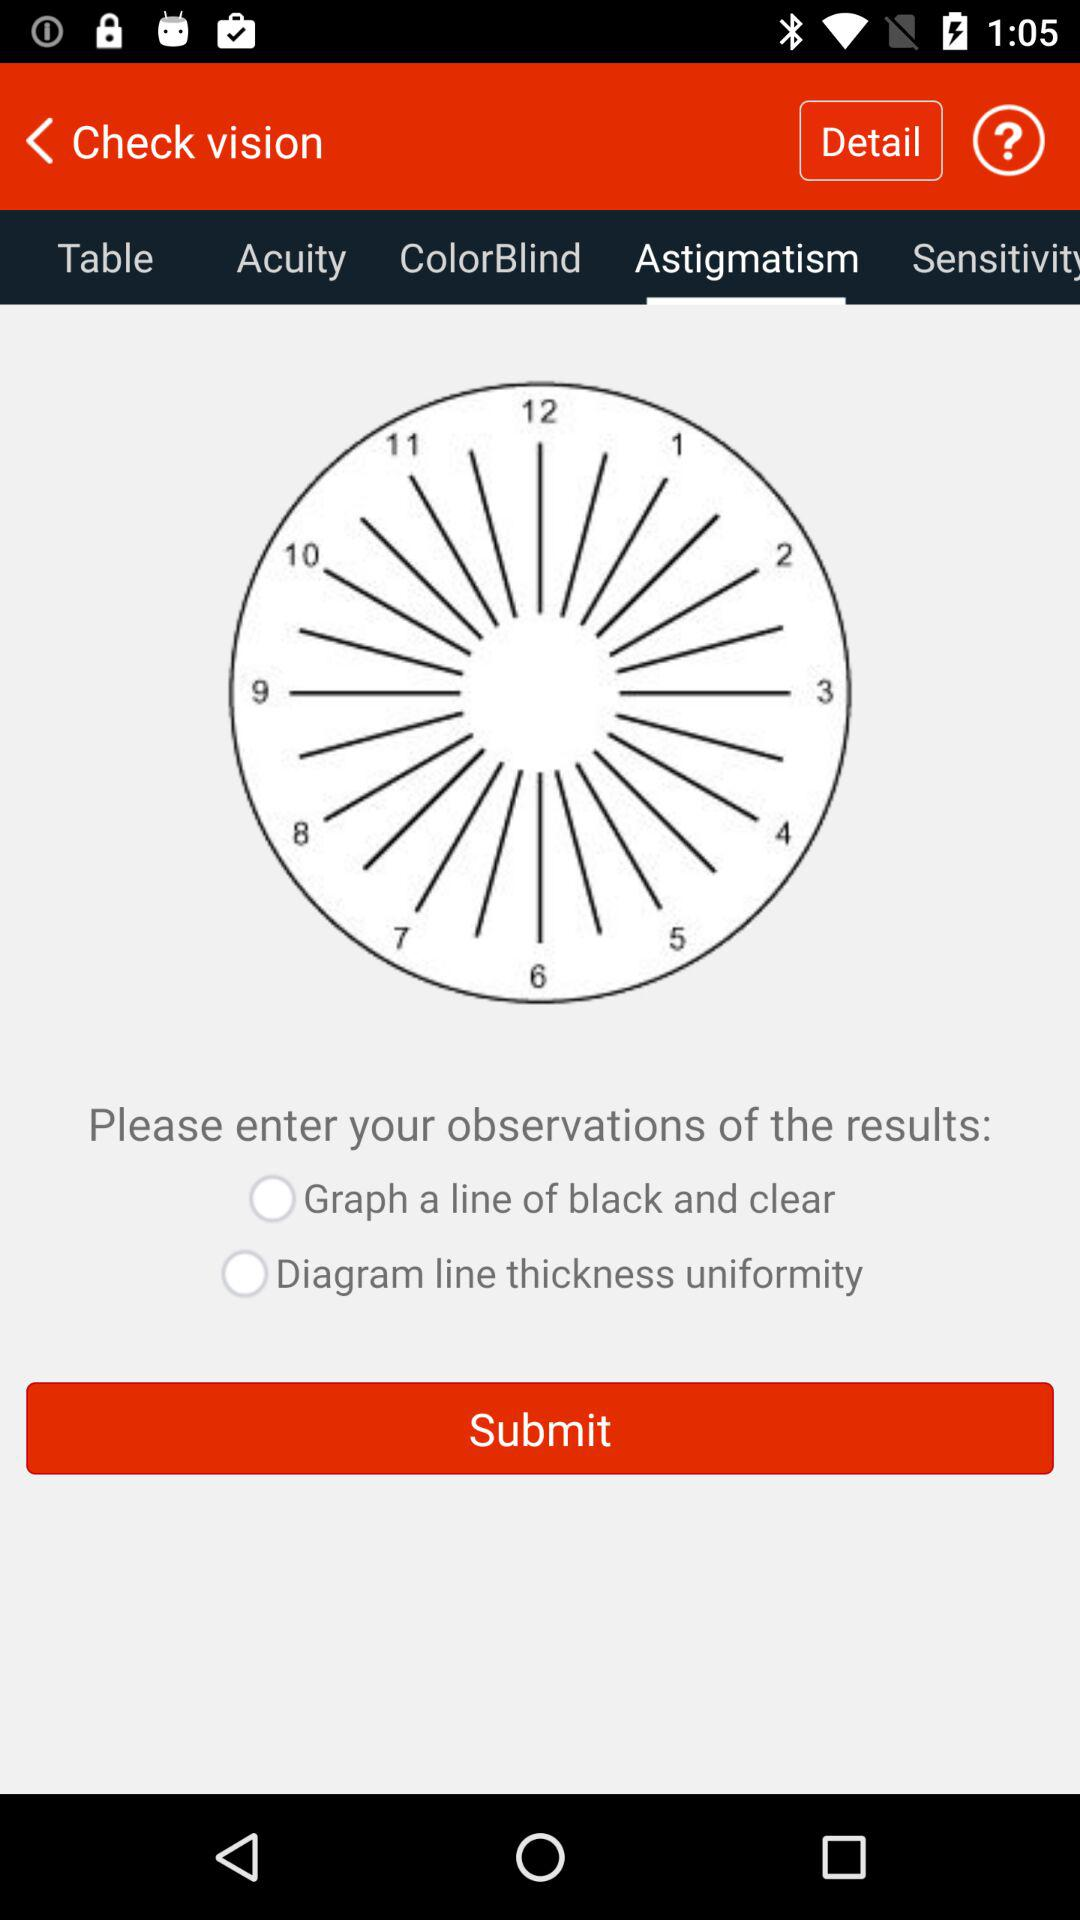What is the selected tab? The selected tab is "Astigmatism". 